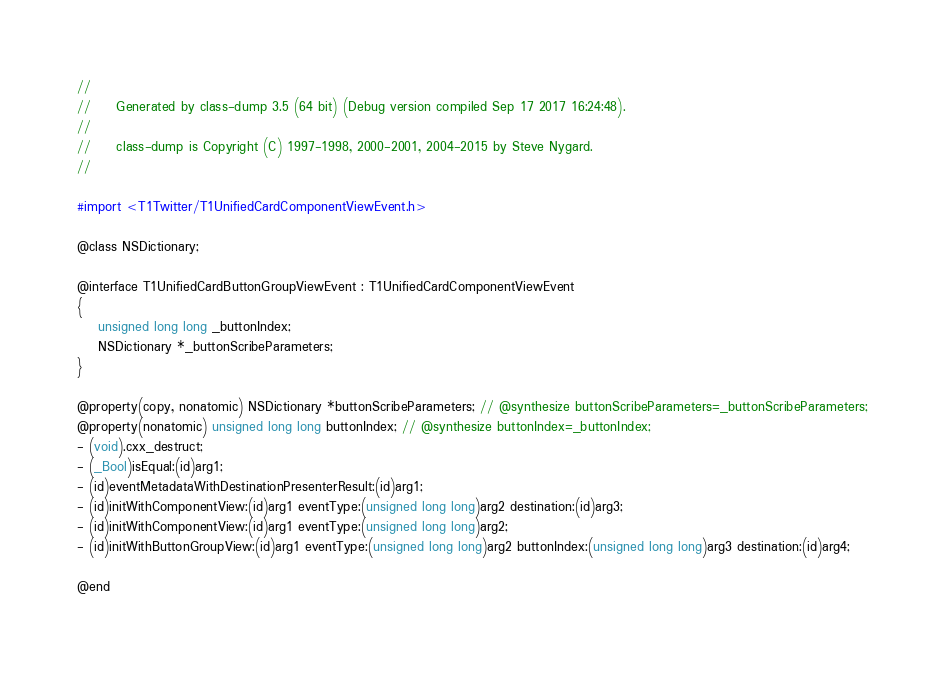Convert code to text. <code><loc_0><loc_0><loc_500><loc_500><_C_>//
//     Generated by class-dump 3.5 (64 bit) (Debug version compiled Sep 17 2017 16:24:48).
//
//     class-dump is Copyright (C) 1997-1998, 2000-2001, 2004-2015 by Steve Nygard.
//

#import <T1Twitter/T1UnifiedCardComponentViewEvent.h>

@class NSDictionary;

@interface T1UnifiedCardButtonGroupViewEvent : T1UnifiedCardComponentViewEvent
{
    unsigned long long _buttonIndex;
    NSDictionary *_buttonScribeParameters;
}

@property(copy, nonatomic) NSDictionary *buttonScribeParameters; // @synthesize buttonScribeParameters=_buttonScribeParameters;
@property(nonatomic) unsigned long long buttonIndex; // @synthesize buttonIndex=_buttonIndex;
- (void).cxx_destruct;
- (_Bool)isEqual:(id)arg1;
- (id)eventMetadataWithDestinationPresenterResult:(id)arg1;
- (id)initWithComponentView:(id)arg1 eventType:(unsigned long long)arg2 destination:(id)arg3;
- (id)initWithComponentView:(id)arg1 eventType:(unsigned long long)arg2;
- (id)initWithButtonGroupView:(id)arg1 eventType:(unsigned long long)arg2 buttonIndex:(unsigned long long)arg3 destination:(id)arg4;

@end

</code> 